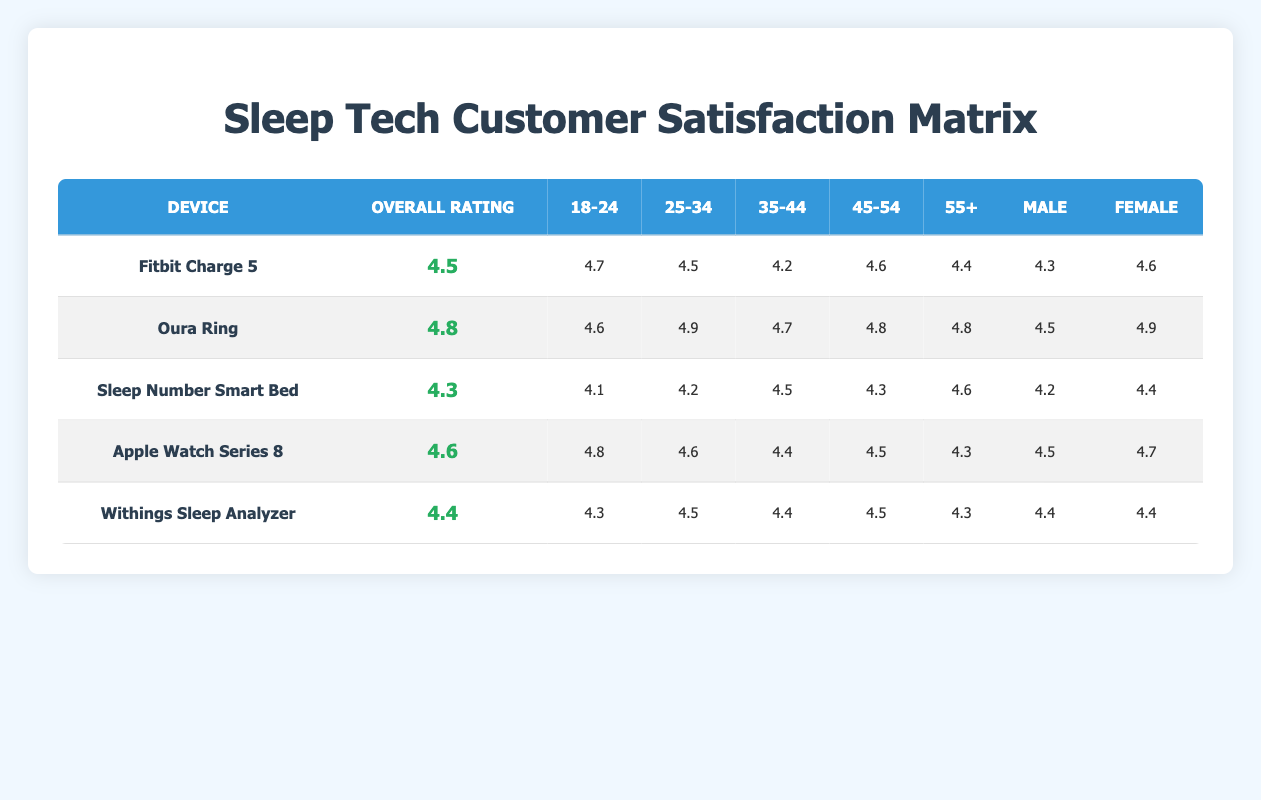What is the overall rating for the Oura Ring? The overall rating for the Oura Ring is found in the second row of the table under the 'Overall Rating' column. It is listed as 4.8.
Answer: 4.8 Which age group has the highest satisfaction rating for the Fitbit Charge 5? To find the highest rating for the Fitbit Charge 5, we can examine the ratings for each age group: 4.7 for 18-24, 4.5 for 25-34, 4.2 for 35-44, 4.6 for 45-54, and 4.4 for 55+. The highest rating is 4.7 for the 18-24 age group.
Answer: 18-24 Is the customer satisfaction rating for males using the Sleep Number Smart Bed higher than that for females? The rating for males using the Sleep Number Smart Bed is 4.2, while for females it is 4.4. Since 4.2 is less than 4.4, the statement is false.
Answer: No What is the average customer satisfaction rating for the 45-54 age group across all devices? We need to sum the ratings for the 45-54 age group for each device: 4.6 (Fitbit Charge 5) + 4.8 (Oura Ring) + 4.3 (Sleep Number Smart Bed) + 4.5 (Apple Watch Series 8) + 4.5 (Withings Sleep Analyzer) = 22.7. There are 5 devices, so the average is 22.7 / 5 = 4.54.
Answer: 4.54 Which device has the lowest customer satisfaction rating overall? By looking down the 'Overall Rating' column, the lowest rating is for the Sleep Number Smart Bed, which is rated 4.3.
Answer: Sleep Number Smart Bed Is it true that both males and females rated the Withings Sleep Analyzer the same? The ratings for males and females using the Withings Sleep Analyzer are both listed as 4.4. Therefore, the statement is true.
Answer: Yes What is the difference in customer satisfaction ratings between the female users of Oura Ring and the Sleep Number Smart Bed? The rating for females using the Oura Ring is 4.9 and for the Sleep Number Smart Bed is 4.4. To find the difference, we subtract 4.4 from 4.9, yielding 4.9 - 4.4 = 0.5.
Answer: 0.5 For which device is the age group 35-44 rated the highest? We analyze the 35-44 age group ratings: 4.2 (Fitbit Charge 5), 4.7 (Oura Ring), 4.5 (Sleep Number Smart Bed), 4.4 (Apple Watch Series 8), and 4.4 (Withings Sleep Analyzer). The highest rating is 4.7 for the Oura Ring.
Answer: Oura Ring 